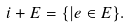<formula> <loc_0><loc_0><loc_500><loc_500>i + E = \{ | e \in E \} .</formula> 